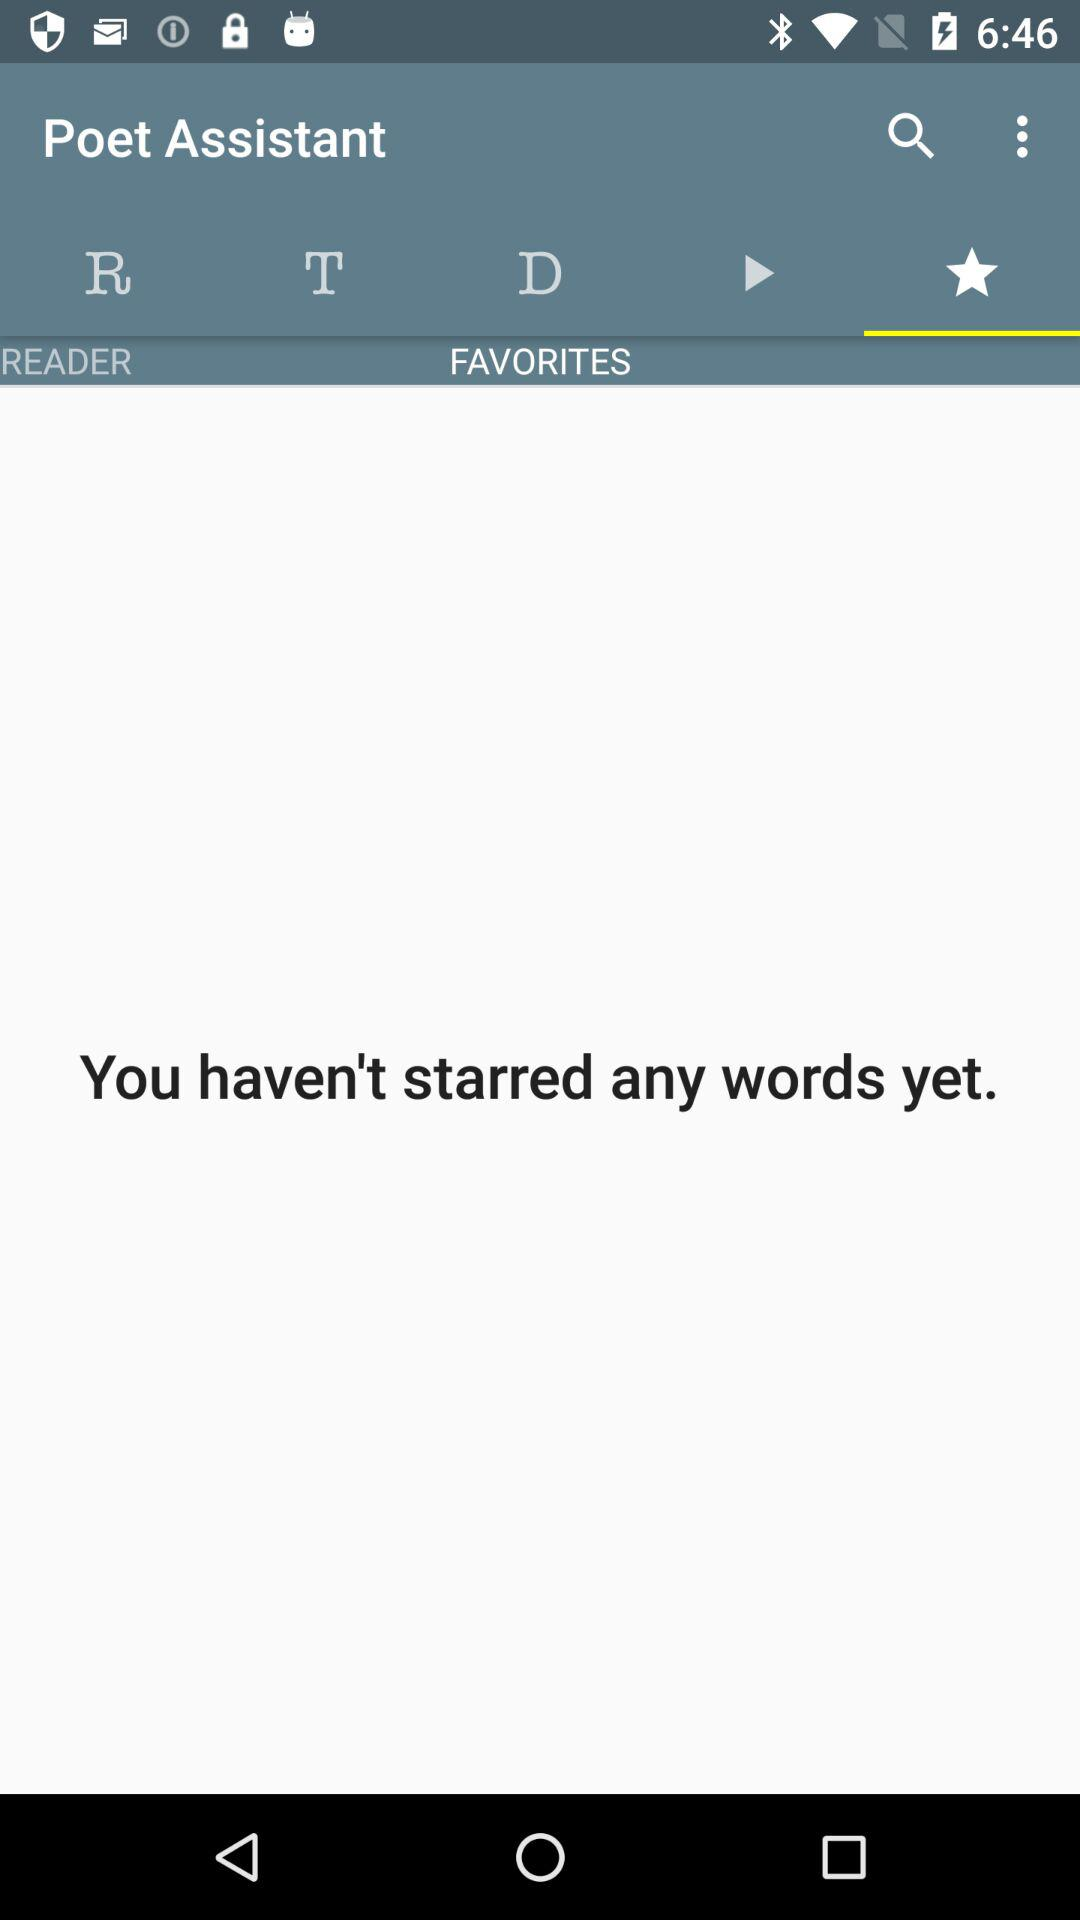What is the name of the application? The name of the application is "Poet Assistant". 